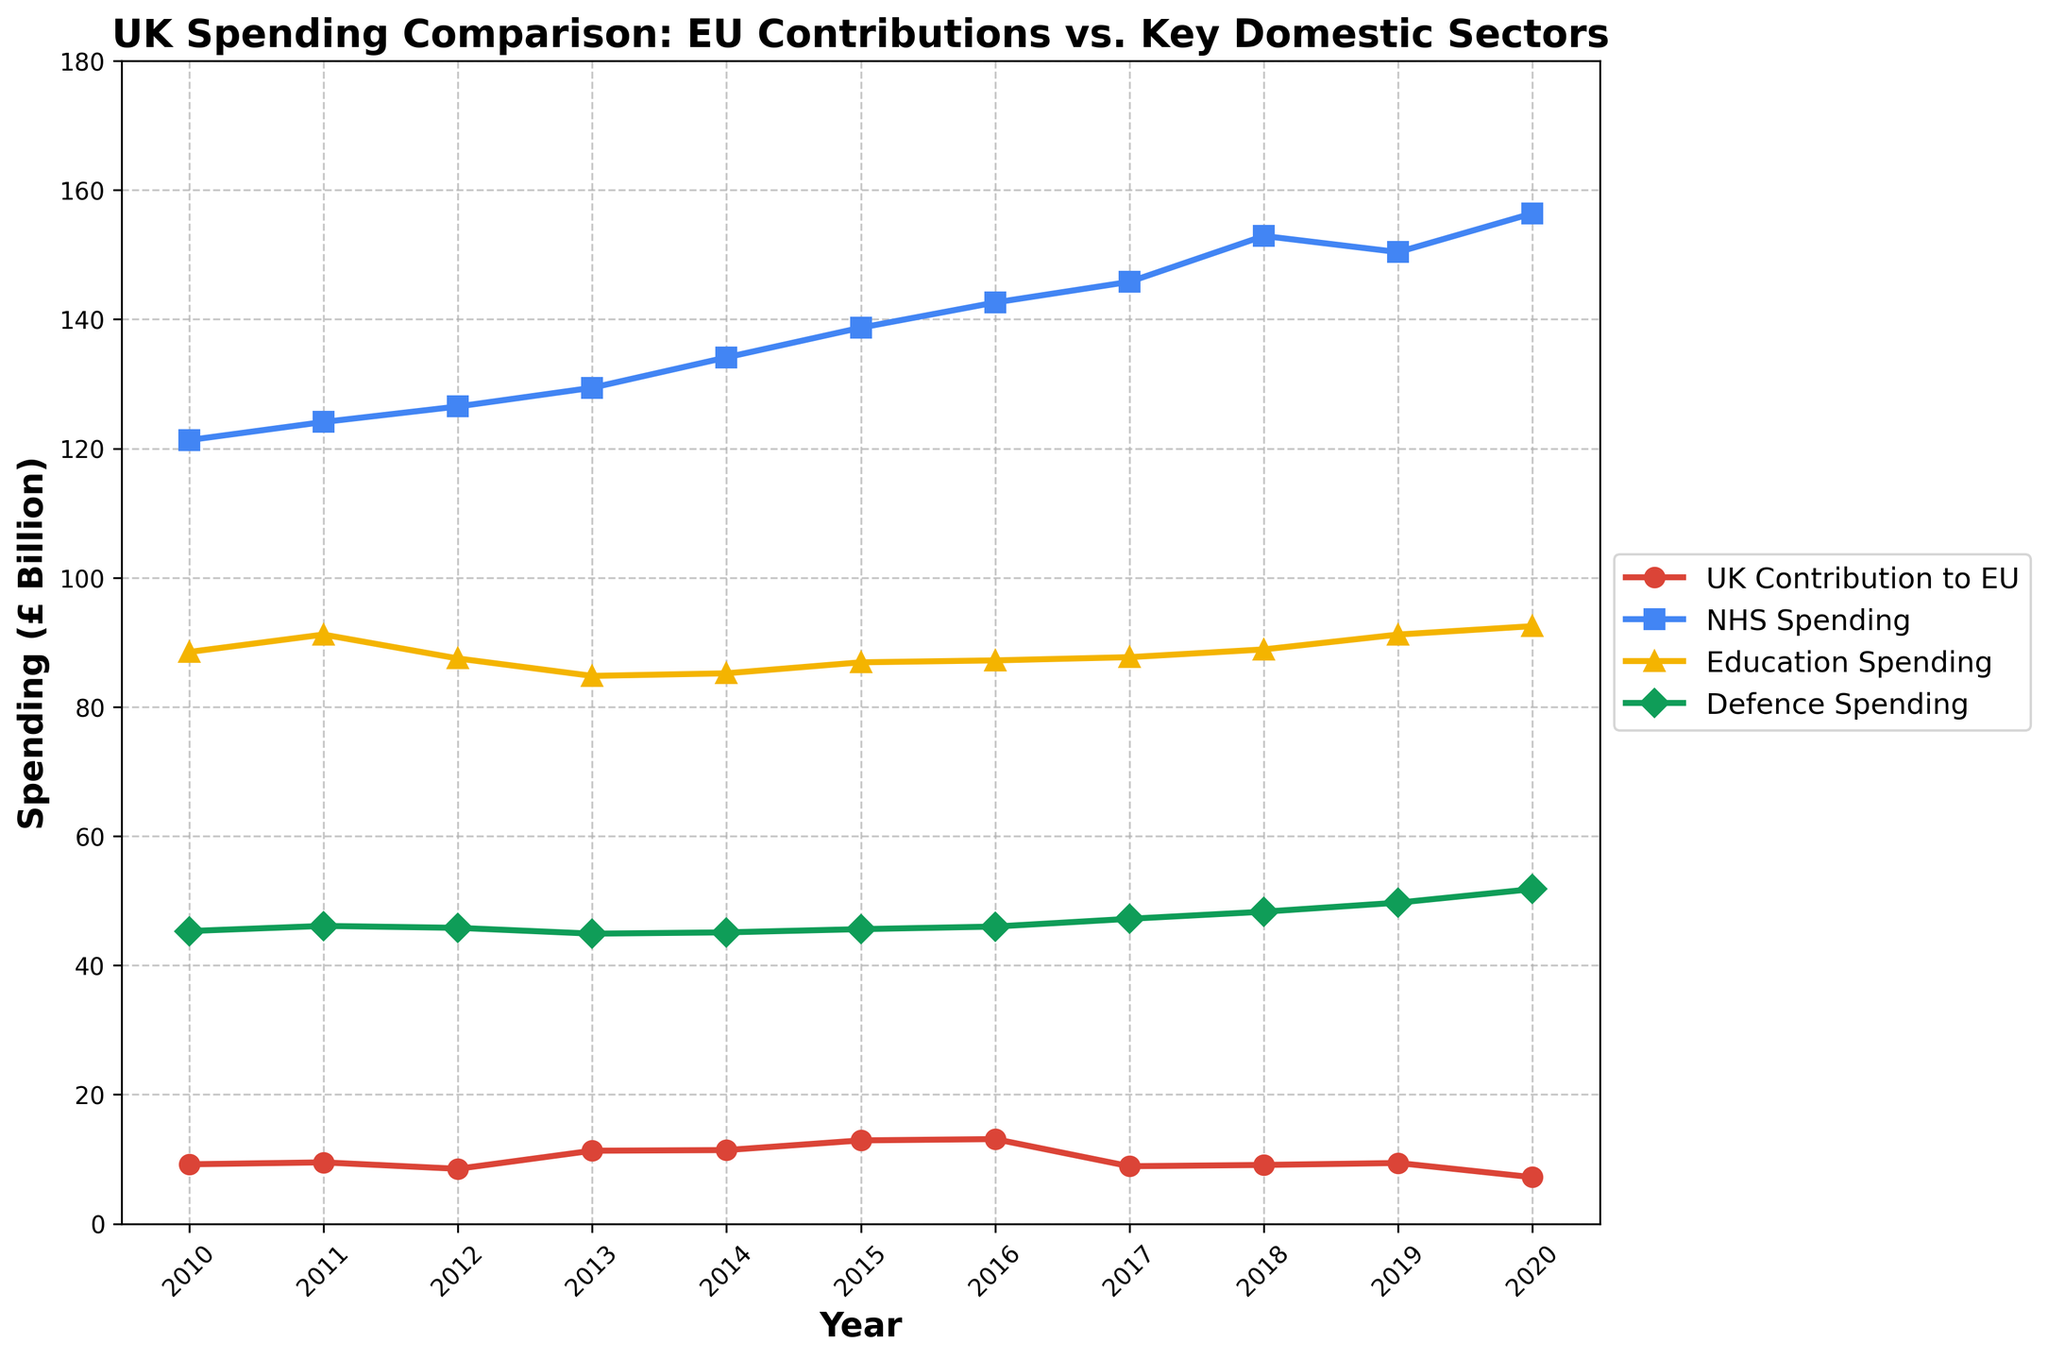What was the UK's contribution to the EU in 2017 compared to NHS spending in the same year? The chart shows the UK's contribution to the EU in 2017 was £8.9 billion, while NHS spending was £145.8 billion. Comparing these values, we see that NHS spending is substantially higher.
Answer: NHS spending is higher What is the overall trend in UK contributions to the EU from 2010 to 2020? By observing the line representing UK contributions to the EU, we see it starts at £9.2 billion in 2010, peaks at £13.1 billion in 2016, and then decreases to its lowest point of £7.2 billion in 2020.
Answer: Decreasing trend after 2016 In which year was the gap between NHS spending and UK contribution to the EU the widest? To find the widest gap, we look for the year with the largest visual distance between the NHS spending and UK contribution lines. The largest gap appears in 2020 when NHS spending is £156.4 billion and UK contribution is £7.2 billion.
Answer: 2020 How does education spending in 2019 compare to NHS spending in the same year? In 2019, the chart shows education spending is £91.2 billion while NHS spending is £150.4 billion. To compare, NHS spending is much higher than education spending.
Answer: NHS spending is higher What is the average NHS spending over the given years? To find the average NHS spending, sum all NHS spending values from 2010 to 2020 and divide by the number of years (11). Sum = 121.3 + 124.1 + 126.5 + 129.4 + 134.1 + 138.7 + 142.6 + 145.8 + 152.9 + 150.4 + 156.4 = 1522.2. Now, divide by 11: 1522.2 / 11 = 138.38 billion.
Answer: £138.38 billion What is the relative change in defence spending between 2010 and 2020? To calculate the relative change, use the formula: (Value at end - Value at start) / Value at start * 100%. Defence spending in 2010 is £45.3 billion and in 2020 is £51.8 billion. Relative change = (51.8 - 45.3) / 45.3 * 100% ≈ 14.35%.
Answer: 14.35% Which year had the lowest UK contribution to the EU and what was the amount? The lowest point of the UK contribution line occurs in 2020, where it is £7.2 billion.
Answer: 2020, £7.2 billion How much more was spent on the NHS than on education in 2015? In 2015, NHS spending was £138.7 billion and education spending was £86.9 billion. The difference is 138.7 - 86.9 = £51.8 billion.
Answer: £51.8 billion What was the trend in education spending from 2013 to 2016? Observing the education spending line from 2013 (£84.8 billion) to 2016 (£87.2 billion), we see a trend of slight fluctuation with an overall slight increase.
Answer: Slight increase Based on the chart, which sector had a relatively stable spending trend over the given years? By examining the lines, Defence spending shows the least fluctuation, maintaining values relatively close to £45–£52 billion throughout the years.
Answer: Defence 